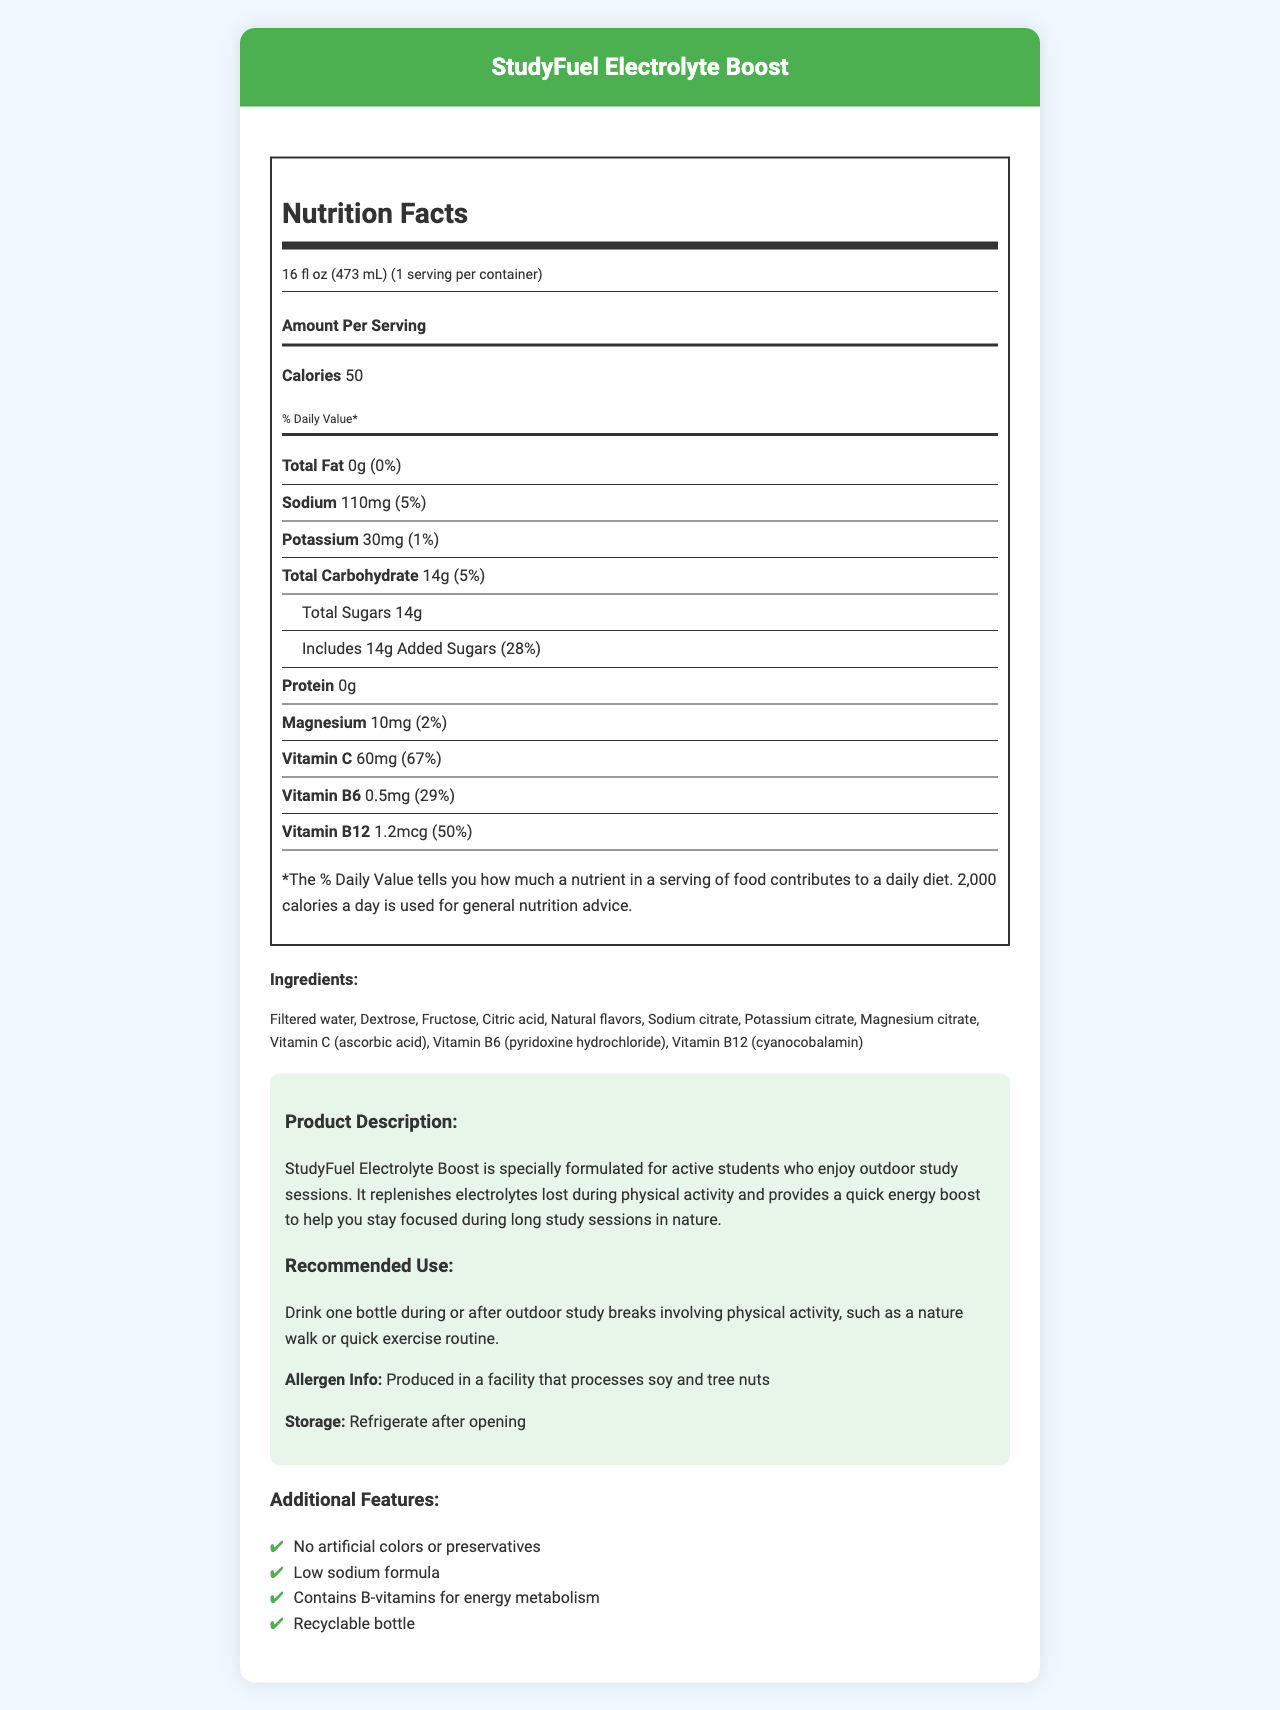what is the serving size? The serving size is directly listed in the document under the nutrition facts section.
Answer: 16 fl oz (473 mL) how much sodium is in one serving? The amount of sodium per serving is listed under the nutrition details.
Answer: 110mg how many calories are in the StudyFuel Electrolyte Boost? The number of calories per serving is stated in the nutrition facts.
Answer: 50 which vitamin has a daily value percentage of 67%? According to the nutrition facts, Vitamin C has a daily value of 67%.
Answer: Vitamin C list three key electrolytes found in the drink. The electrolytes listed in the nutrition facts are sodium, potassium, and magnesium.
Answer: Sodium, Potassium, Magnesium what allergens are mentioned in the document? The allergen information states that the product is produced in a facility that processes soy and tree nuts.
Answer: Soy and tree nuts how much total carbohydrate is there per serving? Under the nutrition facts, the amount of total carbohydrates per serving is shown as 14g.
Answer: 14g what is the recommended use for the StudyFuel Electrolyte Boost? The recommended use is explicitly mentioned in the product description section.
Answer: Drink one bottle during or after outdoor study breaks involving physical activity, such as a nature walk or quick exercise routine. which of the following ingredients is not listed in the document? A. Citric acid B. Dextrose C. High fructose corn syrup D. Vitamin B12 The ingredients list includes citric acid, dextrose, and Vitamin B12, but not high fructose corn syrup.
Answer: C. High fructose corn syrup what percentage of daily value does the added sugars contribute? A. 5% B. 18% C. 28% D. 50% The daily value percentage for added sugars is listed as 28%.
Answer: C. 28% does the product contain artificial colors? The additional features state that the product contains no artificial colors or preservatives.
Answer: No summarize the main purpose of the StudyFuel Electrolyte Boost. The product description specifies that the drink aids in replenishing electrolytes and providing energy for students engaging in outdoor study activities.
Answer: StudyFuel Electrolyte Boost is a hydrating sports drink designed for active students, formulated to replenish electrolytes lost during physical activity and provide energy to stay focused during long study sessions. who is the target audience for this product? The product description and recommended use indicate that the drink is meant for active students studying outdoors.
Answer: Active students who enjoy outdoor study sessions how much protein is in the StudyFuel Electrolyte Boost? The nutrition facts state that there is no protein in the drink.
Answer: 0g what storage instructions are provided for the product? The document advises refrigerating the product after opening.
Answer: Refrigerate after opening can you determine the price of StudyFuel Electrolyte Boost from the provided document? The document does not provide any information regarding the price of the product.
Answer: Cannot be determined 